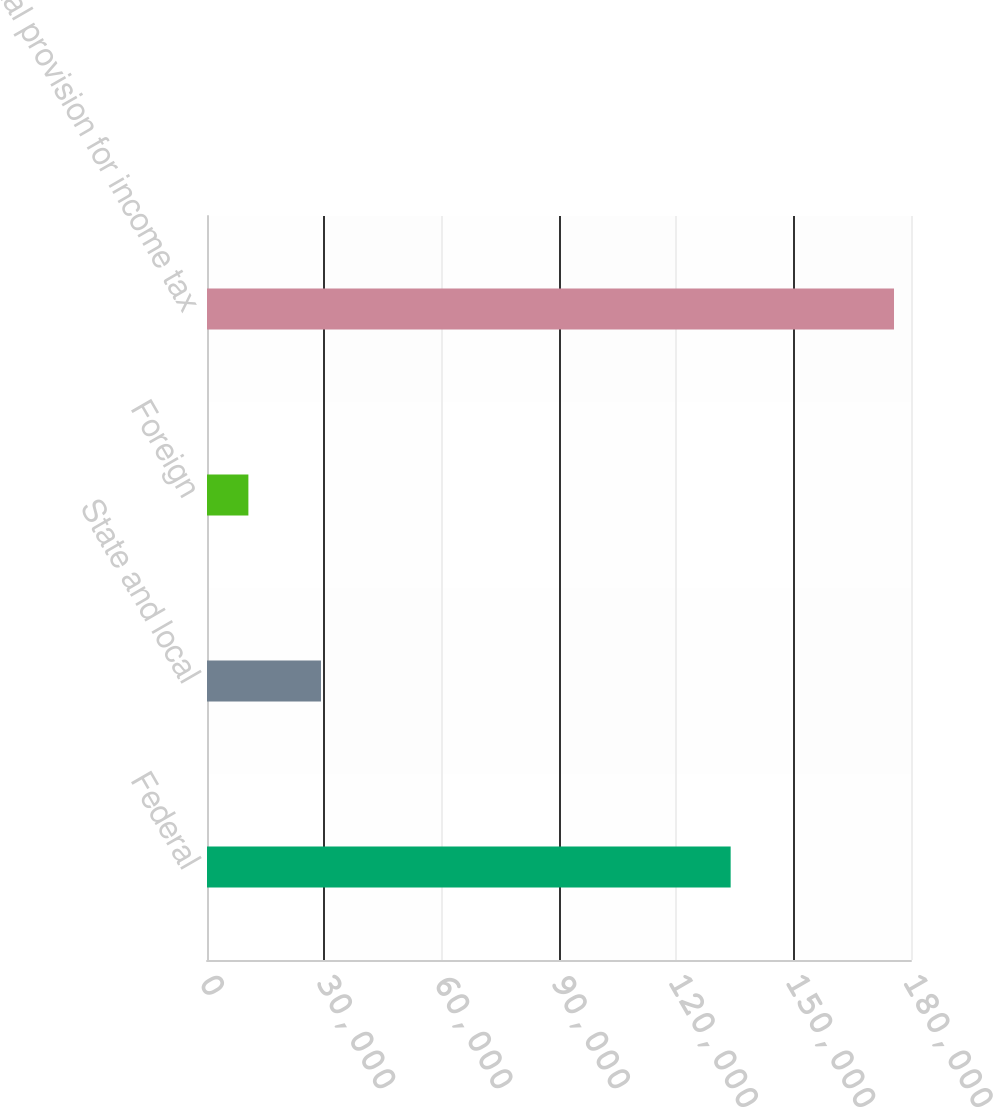<chart> <loc_0><loc_0><loc_500><loc_500><bar_chart><fcel>Federal<fcel>State and local<fcel>Foreign<fcel>Total provision for income tax<nl><fcel>133890<fcel>29141<fcel>10581<fcel>175656<nl></chart> 